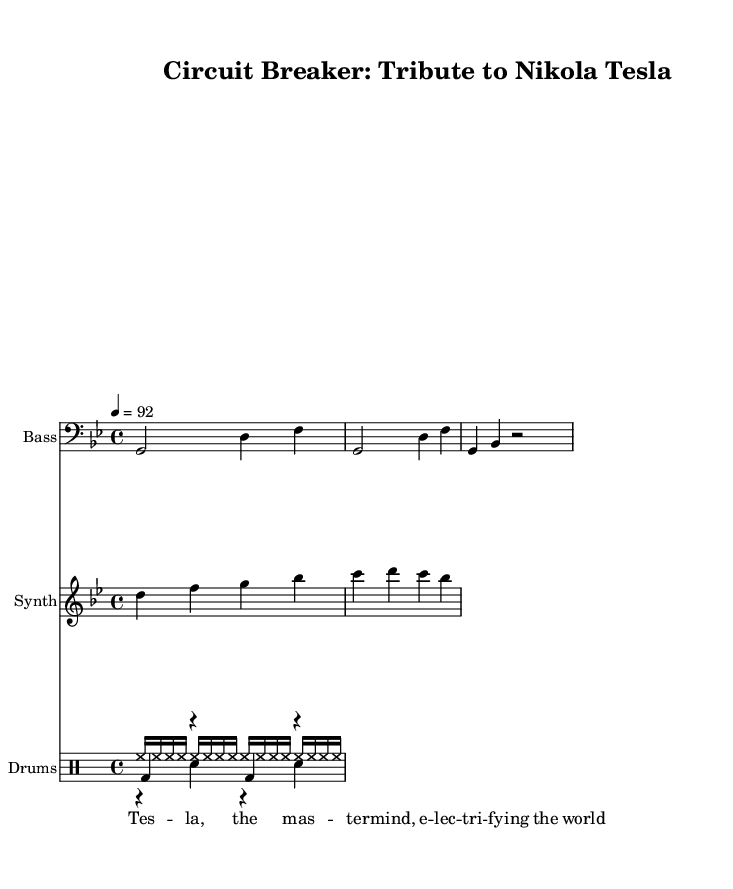what is the key signature of this music? The key signature is G minor, indicated by two flats. This can be determined by looking for the key signature notation at the beginning of the staff.
Answer: G minor what is the time signature of this music? The time signature is 4/4, which means there are four beats in each measure. This is noted at the beginning of the music and is a common time signature used in many music genres.
Answer: 4/4 what is the tempo marking in this music? The tempo marking is 92 beats per minute, indicated by the "4 = 92" notation. This informs the performer of the speed at which to play the music.
Answer: 92 how many measures are in the bass line? There are four measures in the bass line. By counting the groups of notes in the bassMusic, you can see that it repeats after four measures.
Answer: 4 which instrument plays the hihat? The hihat is played by the drums, as indicated by the drum staff. The hihat notation is specifically in the drummode section under the "Drums" instrument name.
Answer: Drums name one inventor celebrated in the sheet music. The inventor celebrated in this music is Nikola Tesla, mentioned in the lyrics. The lyrics attribute the title "Circuit Breaker" as a tribute to his innovative work.
Answer: Nikola Tesla what is the lyric associated with the title of the music? The lyric associated with the title is "Tesla, the master mind, electrifying the world," which celebrates Tesla's influence and contributions to electrical engineering.
Answer: Electrifying the world 